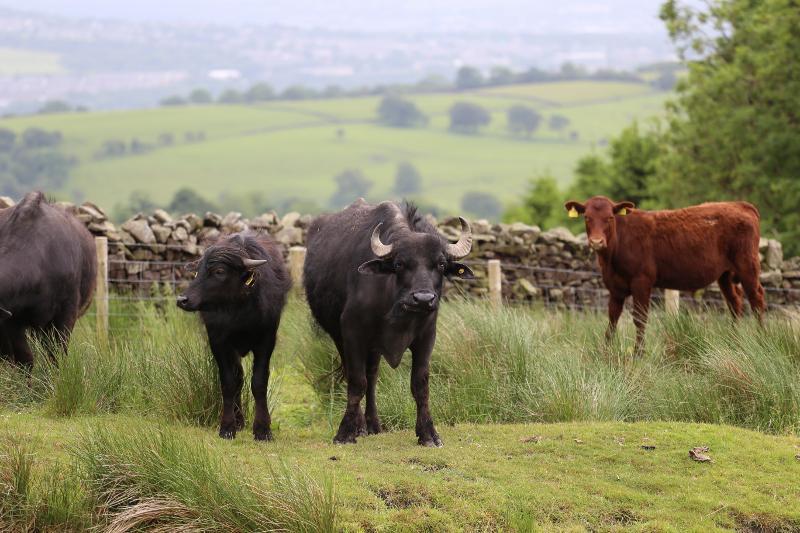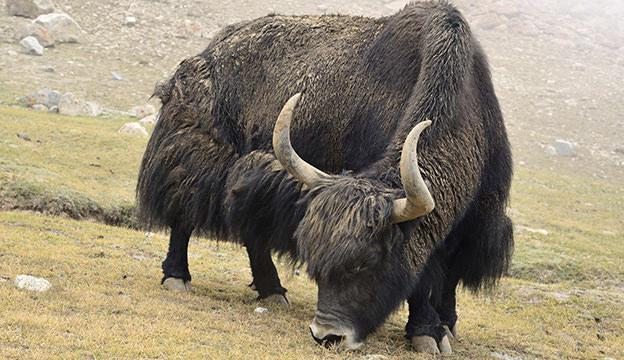The first image is the image on the left, the second image is the image on the right. Evaluate the accuracy of this statement regarding the images: "All the animals have horns.". Is it true? Answer yes or no. No. The first image is the image on the left, the second image is the image on the right. For the images shown, is this caption "In at least one image there is a longhorn bull with his face pointed forward left." true? Answer yes or no. Yes. 